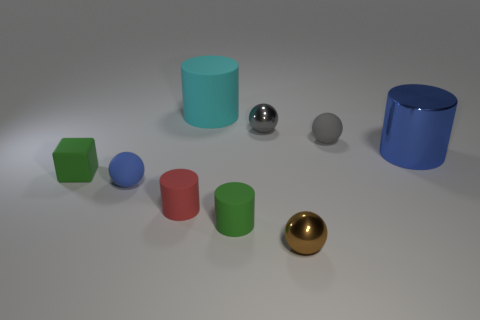Subtract all blue cylinders. How many cylinders are left? 3 Subtract all blue cylinders. How many cylinders are left? 3 Subtract all cubes. How many objects are left? 8 Subtract 3 cylinders. How many cylinders are left? 1 Add 4 small cyan metallic things. How many small cyan metallic things exist? 4 Subtract 0 yellow blocks. How many objects are left? 9 Subtract all gray spheres. Subtract all gray cylinders. How many spheres are left? 2 Subtract all blue cubes. How many gray spheres are left? 2 Subtract all large cyan objects. Subtract all tiny green objects. How many objects are left? 6 Add 4 tiny brown things. How many tiny brown things are left? 5 